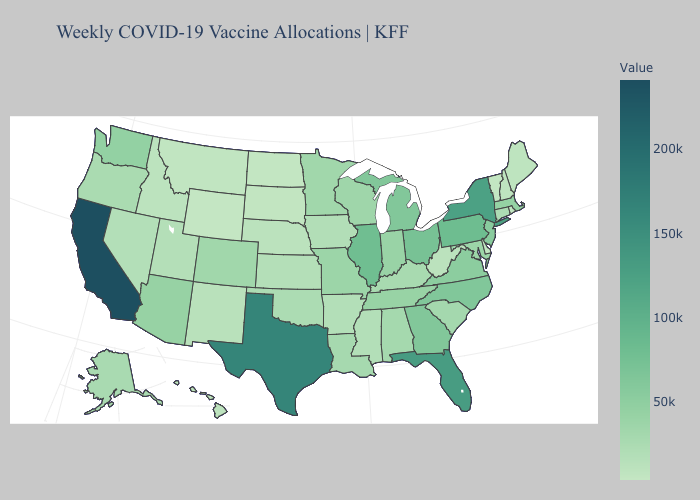Does New Hampshire have the lowest value in the Northeast?
Be succinct. No. Which states have the lowest value in the Northeast?
Answer briefly. Vermont. Is the legend a continuous bar?
Keep it brief. Yes. 